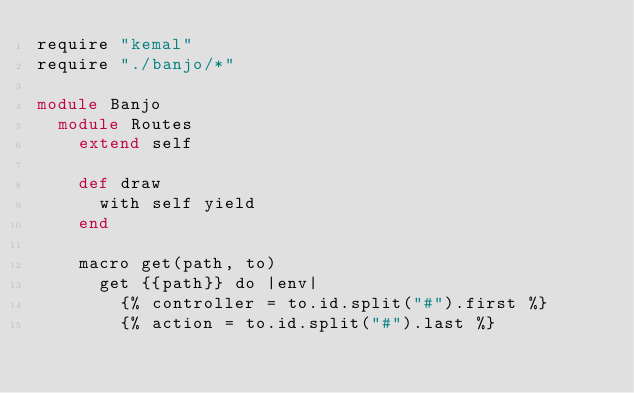Convert code to text. <code><loc_0><loc_0><loc_500><loc_500><_Crystal_>require "kemal"
require "./banjo/*"

module Banjo
  module Routes
    extend self

    def draw
      with self yield
    end

    macro get(path, to)
      get {{path}} do |env|
        {% controller = to.id.split("#").first %}
        {% action = to.id.split("#").last %}</code> 